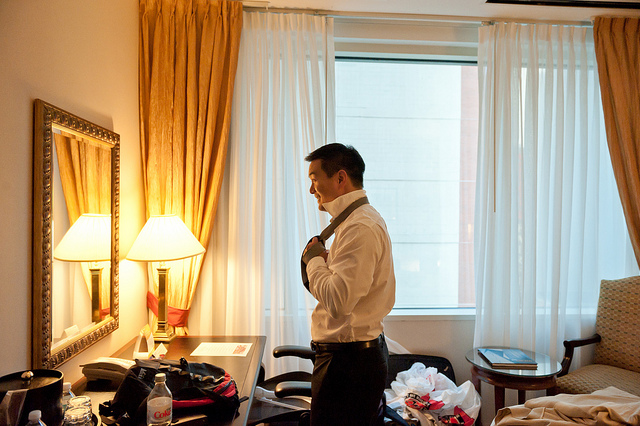Identify the text displayed in this image. Coks 